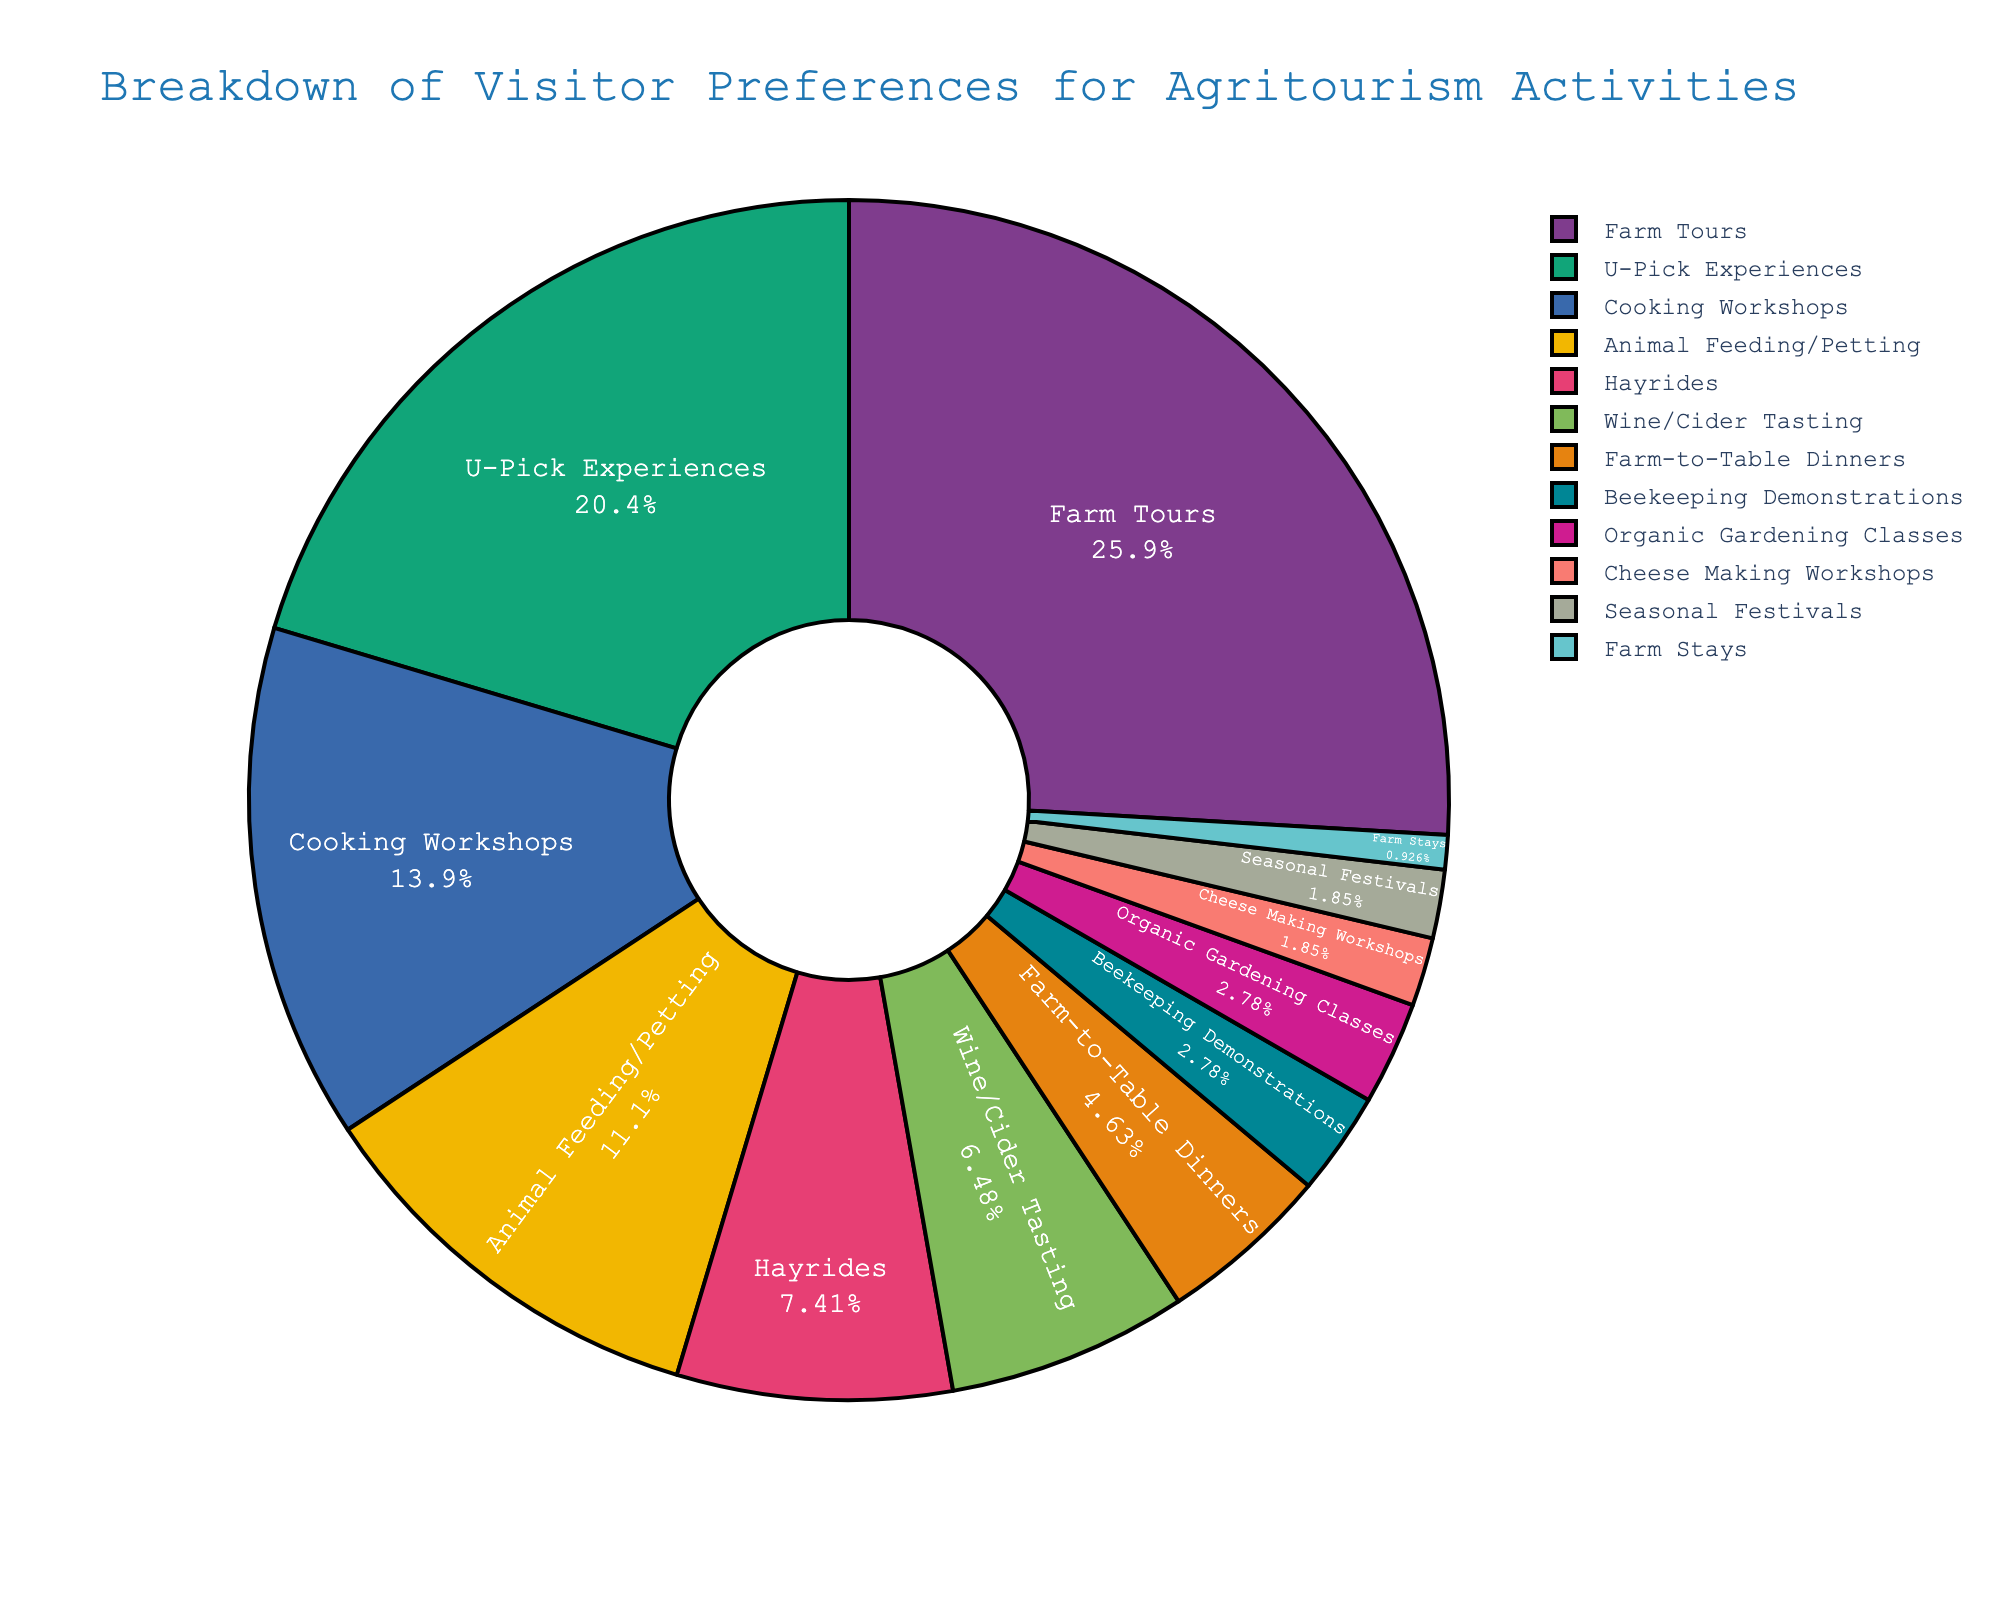What activity is the most preferred by visitors? The pie chart shows that the activity with the highest percentage is Farm Tours, which accounts for 28% of visitor preferences.
Answer: Farm Tours Which two activities have the lowest visitor preferences? By observing the smallest sections of the pie chart, the activities with the lowest percentages are Farm Stays at 1% and Cheese Making Workshops and Seasonal Festivals both at 2%.
Answer: Farm Stays, Cheese Making Workshops, and Seasonal Festivals What is the combined percentage of visitor preferences for U-Pick Experiences and Animal Feeding/Petting? The pie chart indicates that U-Pick Experiences account for 22% and Animal Feeding/Petting account for 12%. Adding these together gives 22% + 12% = 34%.
Answer: 34% Is the percentage for Cooking Workshops higher or lower than for Wine/Cider Tasting? By comparing the sections, Cooking Workshops have 15% while Wine/Cider Tasting has 7%. Therefore, Cooking Workshops have a higher percentage than Wine/Cider Tasting.
Answer: Higher What is the difference in visitor preference percentages between Farm Tours and Hayrides? The chart shows that Farm Tours account for 28% and Hayrides account for 8%. The difference is 28% - 8% = 20%.
Answer: 20% How does the preference for U-Pick Experiences compare to Cooking Workshops in terms of percentage? U-Pick Experiences are at 22% while Cooking Workshops are at 15%. Comparatively, U-Pick Experiences have a higher percentage than Cooking Workshops.
Answer: Higher What is the total percentage for activities related to workshops (e.g., Cooking Workshops, Organic Gardening Classes, Cheese Making Workshops)? The chart has Cooking Workshops at 15%, Organic Gardening Classes at 3%, and Cheese Making Workshops at 2%. Adding these gives 15% + 3% + 2% = 20%.
Answer: 20% Which activity accounts for a higher percentage: Beekeeping Demonstrations or Animal Feeding/Petting? The pie chart shows that Animal Feeding/Petting is at 12%, while Beekeeping Demonstrations are at 3%. Thus, Animal Feeding/Petting has a higher percentage than Beekeeping Demonstrations.
Answer: Animal Feeding/Petting What activities constitute the middle 50% range of visitor preferences? To determine the middle 50%, you need to look for activities whose combined percentages fall around 50%. Starting from the highest percentages: Farm Tours (28%) + U-Pick Experiences (22%) = 50%.
Answer: Farm Tours, U-Pick Experiences 